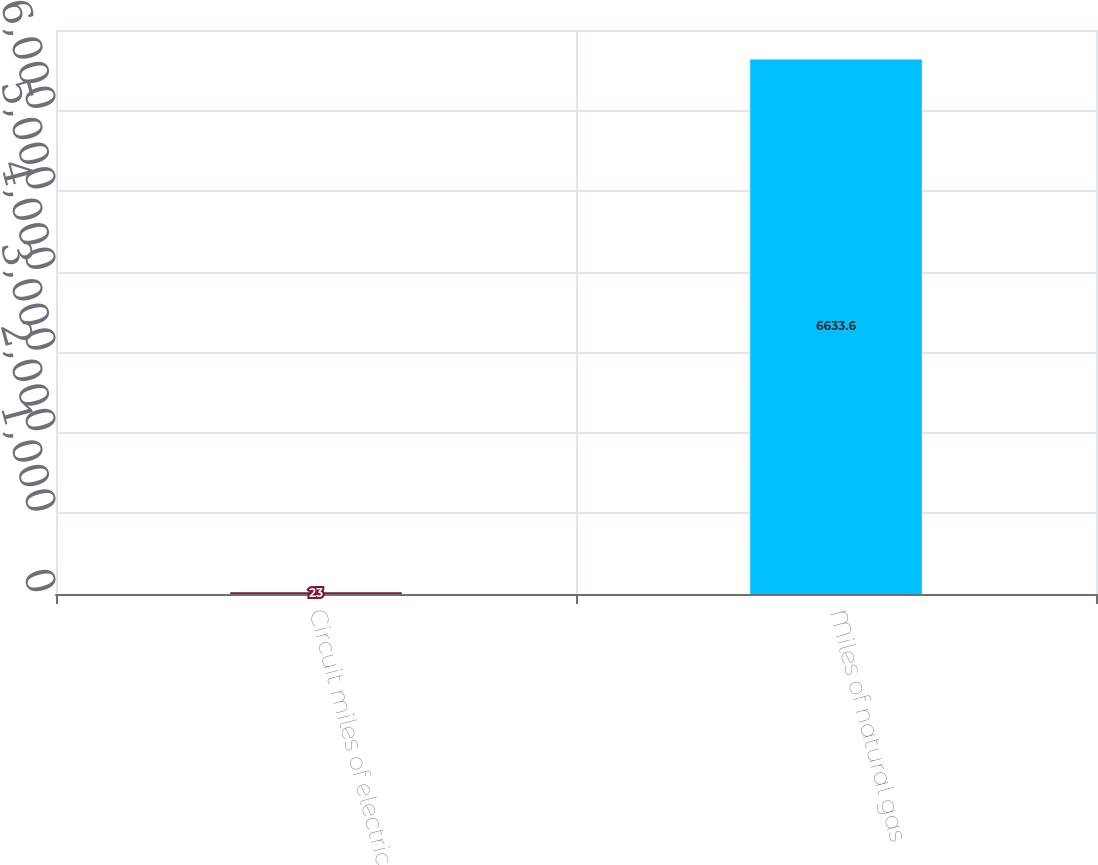<chart> <loc_0><loc_0><loc_500><loc_500><bar_chart><fcel>Circuit miles of electric<fcel>Miles of natural gas<nl><fcel>23<fcel>6633.6<nl></chart> 